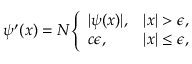Convert formula to latex. <formula><loc_0><loc_0><loc_500><loc_500>\psi ^ { \prime } ( x ) = N { \left \{ \begin{array} { l l } { | \psi ( x ) | , } & { | x | > \epsilon , } \\ { c \epsilon , } & { | x | \leq \epsilon , } \end{array} }</formula> 